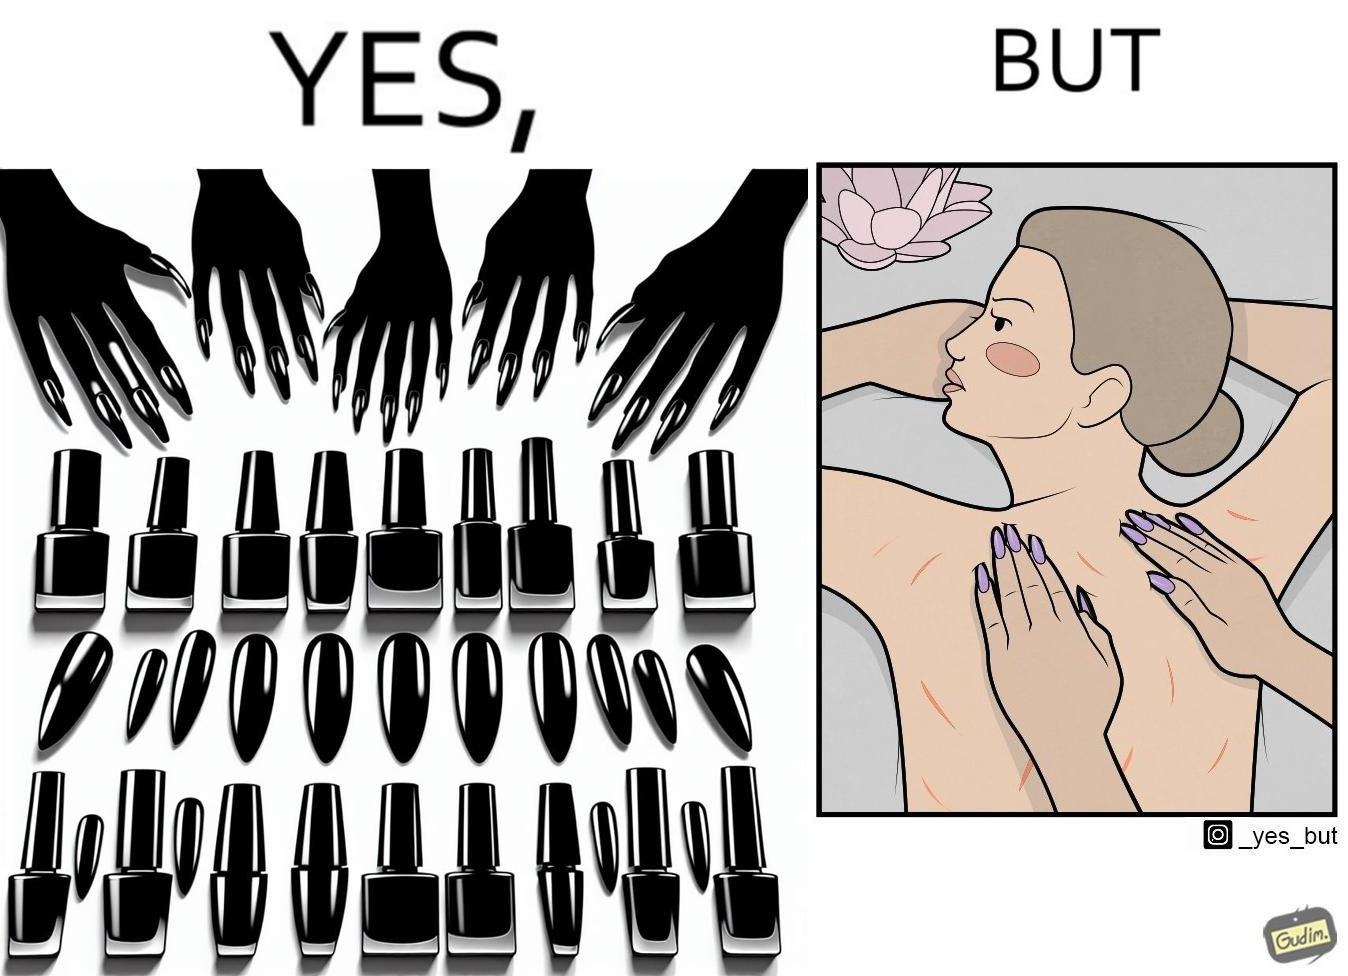Compare the left and right sides of this image. In the left part of the image: They are nails with nail polish In the right part of the image: It is an image of a woman with scratches on her back, possibly due to the nails of the masseuse digging into her back 